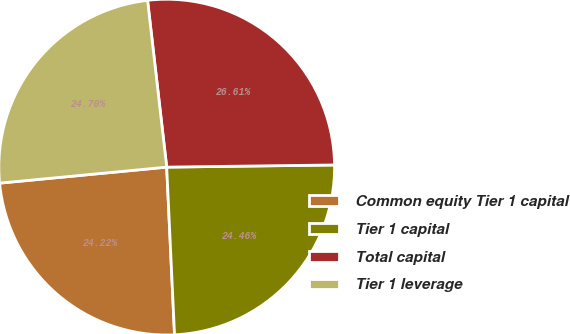Convert chart to OTSL. <chart><loc_0><loc_0><loc_500><loc_500><pie_chart><fcel>Common equity Tier 1 capital<fcel>Tier 1 capital<fcel>Total capital<fcel>Tier 1 leverage<nl><fcel>24.22%<fcel>24.46%<fcel>26.61%<fcel>24.7%<nl></chart> 